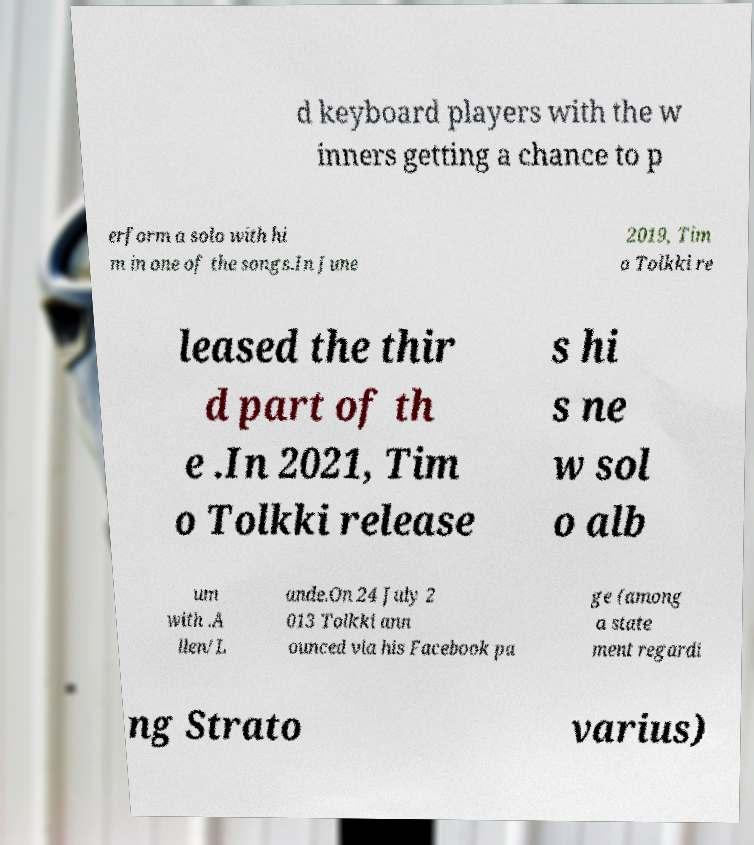Could you assist in decoding the text presented in this image and type it out clearly? d keyboard players with the w inners getting a chance to p erform a solo with hi m in one of the songs.In June 2019, Tim o Tolkki re leased the thir d part of th e .In 2021, Tim o Tolkki release s hi s ne w sol o alb um with .A llen/L ande.On 24 July 2 013 Tolkki ann ounced via his Facebook pa ge (among a state ment regardi ng Strato varius) 